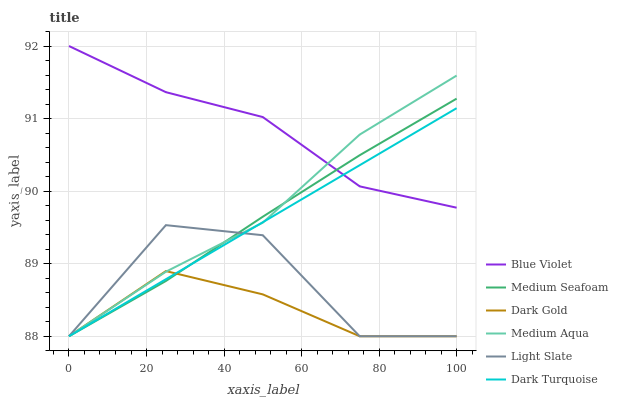Does Dark Gold have the minimum area under the curve?
Answer yes or no. Yes. Does Blue Violet have the maximum area under the curve?
Answer yes or no. Yes. Does Light Slate have the minimum area under the curve?
Answer yes or no. No. Does Light Slate have the maximum area under the curve?
Answer yes or no. No. Is Dark Turquoise the smoothest?
Answer yes or no. Yes. Is Light Slate the roughest?
Answer yes or no. Yes. Is Light Slate the smoothest?
Answer yes or no. No. Is Dark Turquoise the roughest?
Answer yes or no. No. Does Dark Gold have the lowest value?
Answer yes or no. Yes. Does Blue Violet have the lowest value?
Answer yes or no. No. Does Blue Violet have the highest value?
Answer yes or no. Yes. Does Light Slate have the highest value?
Answer yes or no. No. Is Light Slate less than Blue Violet?
Answer yes or no. Yes. Is Blue Violet greater than Dark Gold?
Answer yes or no. Yes. Does Dark Turquoise intersect Blue Violet?
Answer yes or no. Yes. Is Dark Turquoise less than Blue Violet?
Answer yes or no. No. Is Dark Turquoise greater than Blue Violet?
Answer yes or no. No. Does Light Slate intersect Blue Violet?
Answer yes or no. No. 